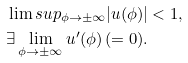<formula> <loc_0><loc_0><loc_500><loc_500>& \lim s u p _ { \phi \to \pm \infty } | u ( \phi ) | < 1 , \\ & \exists \lim _ { \phi \to \pm \infty } { u ^ { \prime } ( \phi ) } \, ( = 0 ) .</formula> 